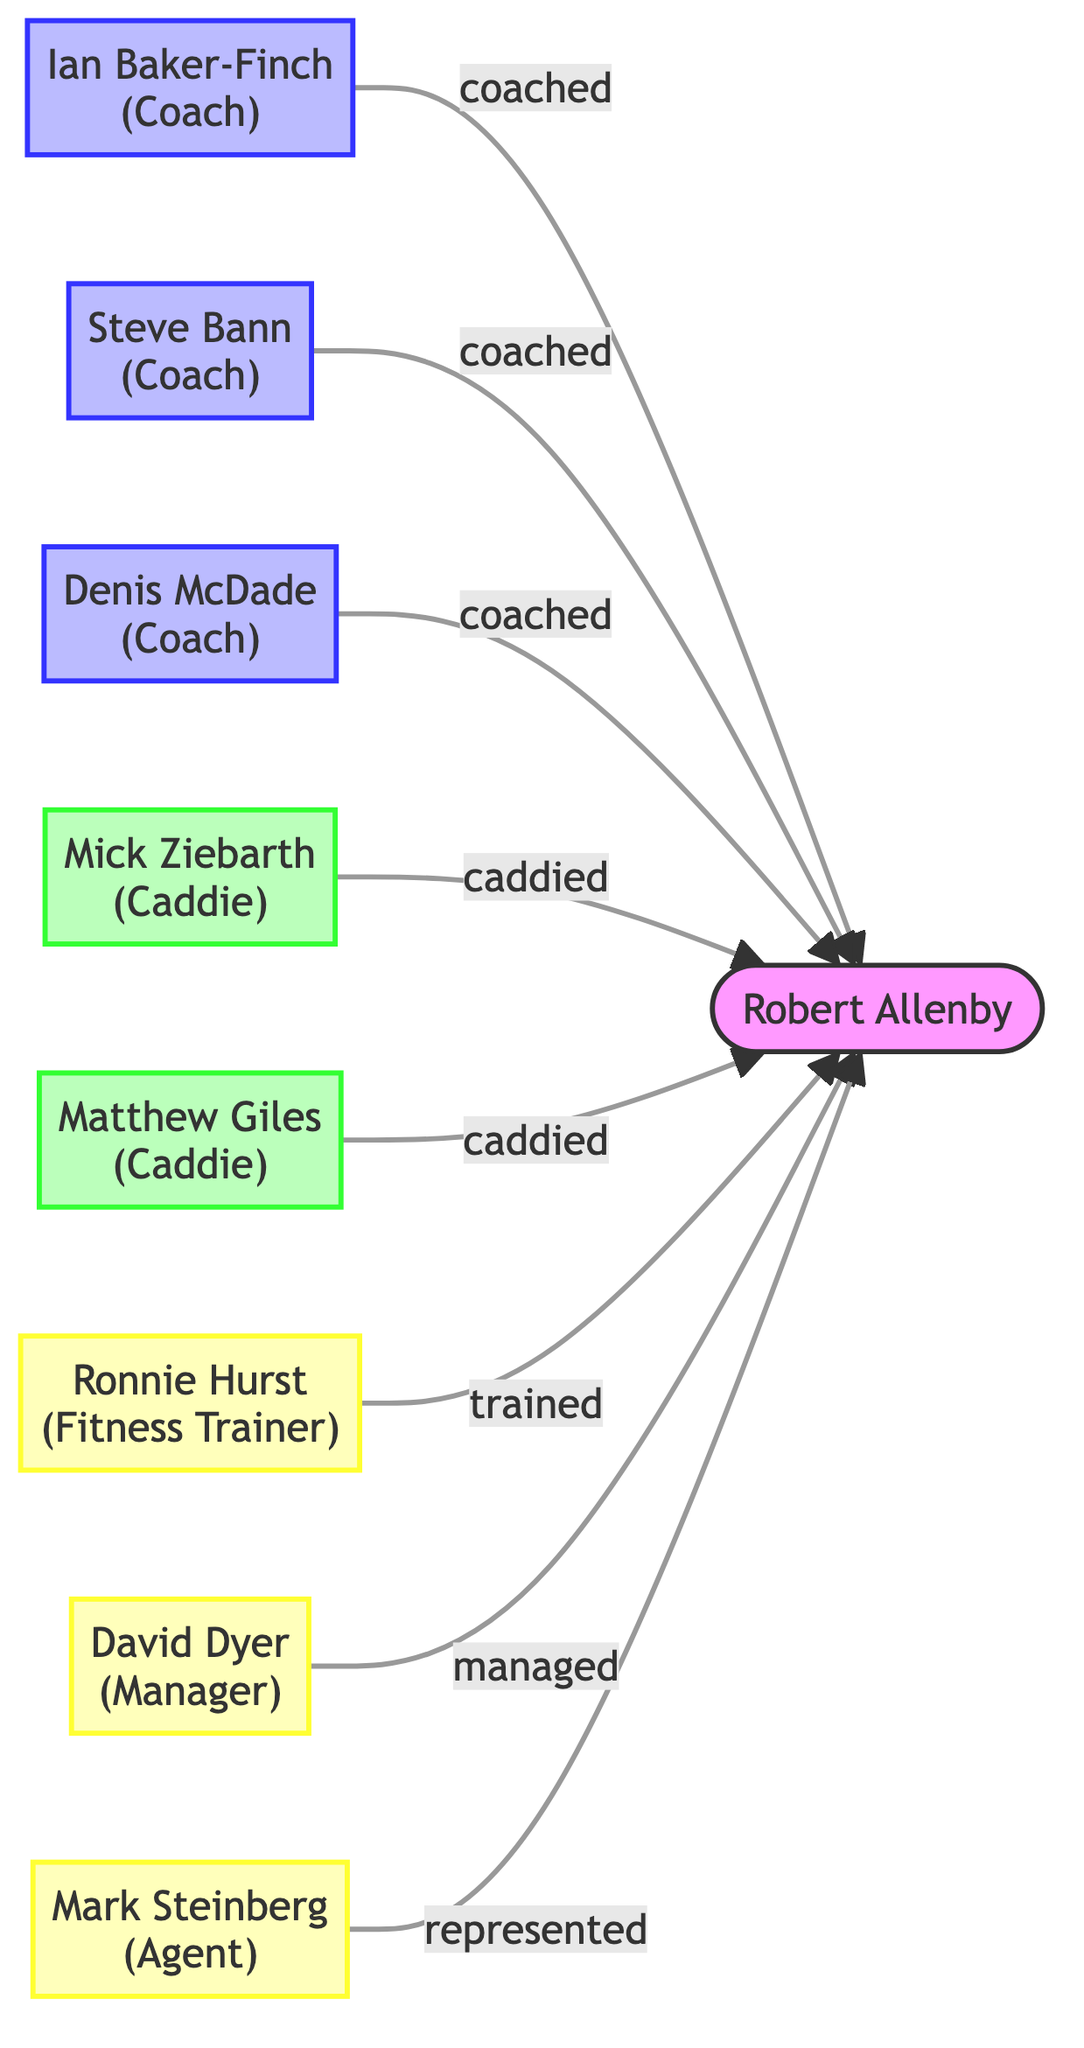What is the total number of nodes in the diagram? Count the nodes listed in the dataset. There are 9 nodes: Robert Allenby, Ian Baker-Finch, Steve Bann, Denis McDade, Mick Ziebarth, Matthew Giles, Ronnie Hurst, David Dyer, and Mark Steinberg.
Answer: 9 Who is represented by Mark Steinberg? The edge from Mark Steinberg indicates that he represents Robert Allenby. This is derived from the directed relationship labeled "represented".
Answer: Robert Allenby How many coaches are involved in Robert Allenby's career? Identify the nodes that represent coaches: Ian Baker-Finch, Steve Bann, and Denis McDade. There are three edges leading from distinct coaches to Robert Allenby.
Answer: 3 What type of support does Ronnie Hurst provide to Robert Allenby? Look at the edge connected to Ronnie Hurst, which is labeled "trained". This shows the specific type of support given by him.
Answer: trained Which caddie worked with Robert Allenby last, based on the diagram? Both Mick Ziebarth and Matthew Giles are listed as caddies for Robert Allenby, but their order in the diagram does not indicate a sequence. The question can't be answered with certainty, but you could mention both. The edge to Robert Allenby shows they both have roles without specifying who was last.
Answer: None (uncertain) Which staff member has the role of manager? The edge leading from David Dyer to Robert Allenby is labeled "managed", indicating that David Dyer is the manager for Robert Allenby.
Answer: David Dyer How many edges are present in the diagram? Count the number of directed connections; there are 8 edges which connect the various nodes to Robert Allenby.
Answer: 8 Who has coached Robert Allenby the longest? The diagram does not provide temporal relationships or duration of coaching roles. Hence, there is no way to discern who coached Allenby the longest based solely on this diagram.
Answer: None (uncertain) 